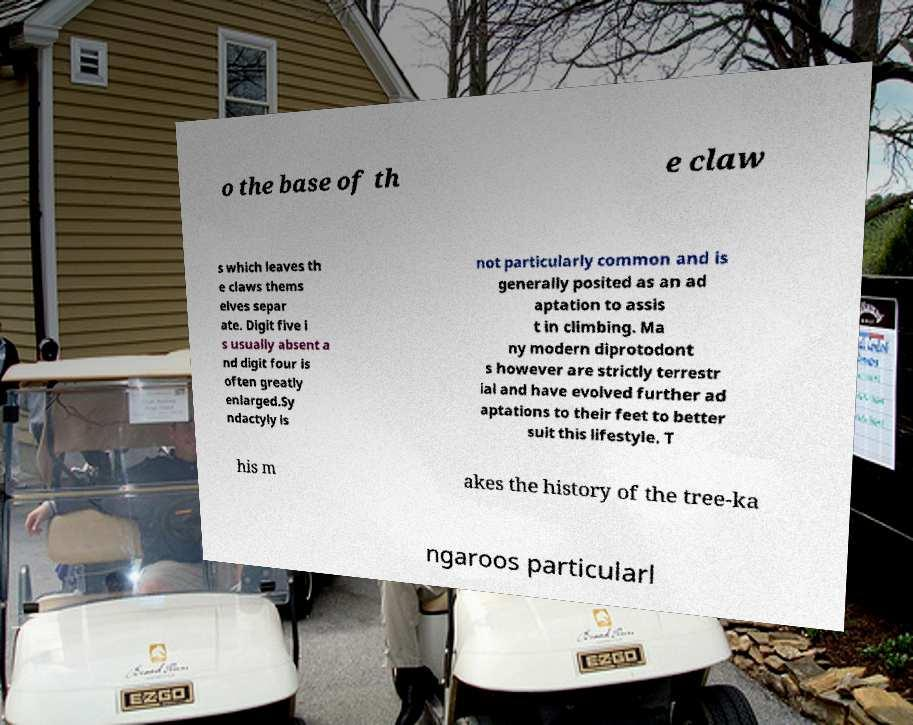Can you read and provide the text displayed in the image?This photo seems to have some interesting text. Can you extract and type it out for me? o the base of th e claw s which leaves th e claws thems elves separ ate. Digit five i s usually absent a nd digit four is often greatly enlarged.Sy ndactyly is not particularly common and is generally posited as an ad aptation to assis t in climbing. Ma ny modern diprotodont s however are strictly terrestr ial and have evolved further ad aptations to their feet to better suit this lifestyle. T his m akes the history of the tree-ka ngaroos particularl 